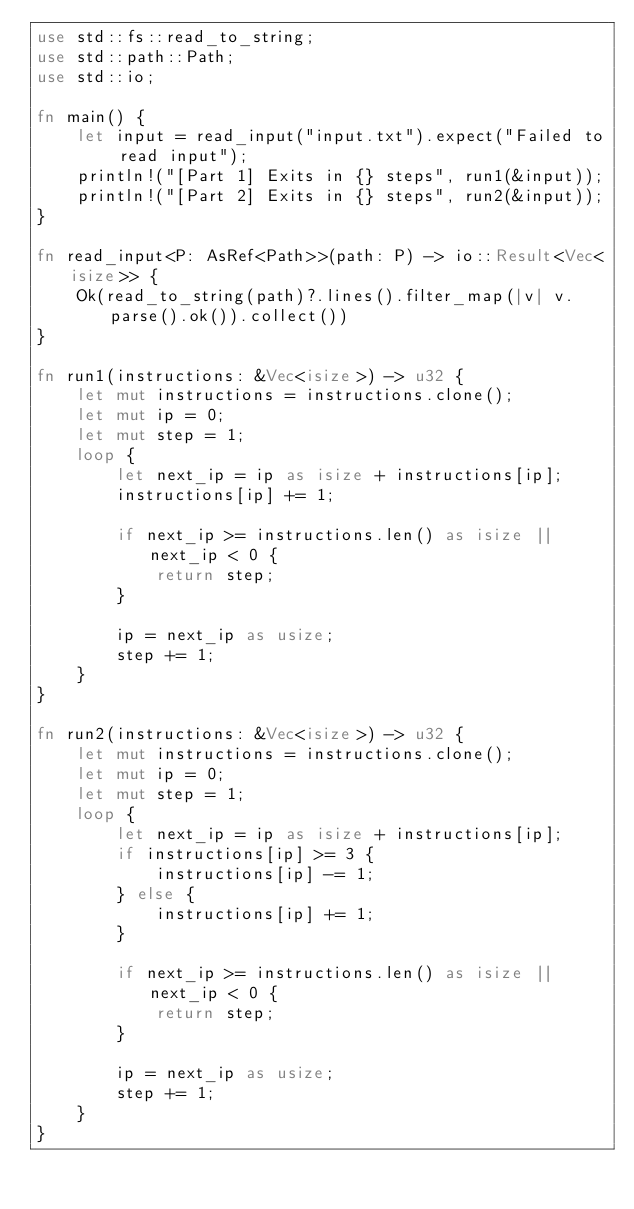<code> <loc_0><loc_0><loc_500><loc_500><_Rust_>use std::fs::read_to_string;
use std::path::Path;
use std::io;

fn main() {
    let input = read_input("input.txt").expect("Failed to read input");
    println!("[Part 1] Exits in {} steps", run1(&input));
    println!("[Part 2] Exits in {} steps", run2(&input));
}

fn read_input<P: AsRef<Path>>(path: P) -> io::Result<Vec<isize>> {
    Ok(read_to_string(path)?.lines().filter_map(|v| v.parse().ok()).collect())
}

fn run1(instructions: &Vec<isize>) -> u32 {
    let mut instructions = instructions.clone();
    let mut ip = 0;
    let mut step = 1;
    loop {
        let next_ip = ip as isize + instructions[ip];
        instructions[ip] += 1;

        if next_ip >= instructions.len() as isize || next_ip < 0 {
            return step;
        }

        ip = next_ip as usize;
        step += 1;
    }
}

fn run2(instructions: &Vec<isize>) -> u32 {
    let mut instructions = instructions.clone();
    let mut ip = 0;
    let mut step = 1;
    loop {
        let next_ip = ip as isize + instructions[ip];
        if instructions[ip] >= 3 {
            instructions[ip] -= 1;
        } else {
            instructions[ip] += 1;
        }

        if next_ip >= instructions.len() as isize || next_ip < 0 {
            return step;
        }

        ip = next_ip as usize;
        step += 1;
    }
}
</code> 